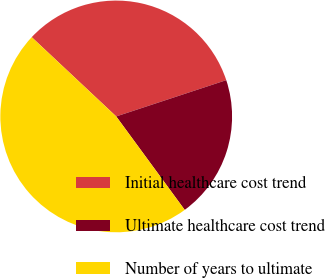Convert chart to OTSL. <chart><loc_0><loc_0><loc_500><loc_500><pie_chart><fcel>Initial healthcare cost trend<fcel>Ultimate healthcare cost trend<fcel>Number of years to ultimate<nl><fcel>32.94%<fcel>20.0%<fcel>47.06%<nl></chart> 